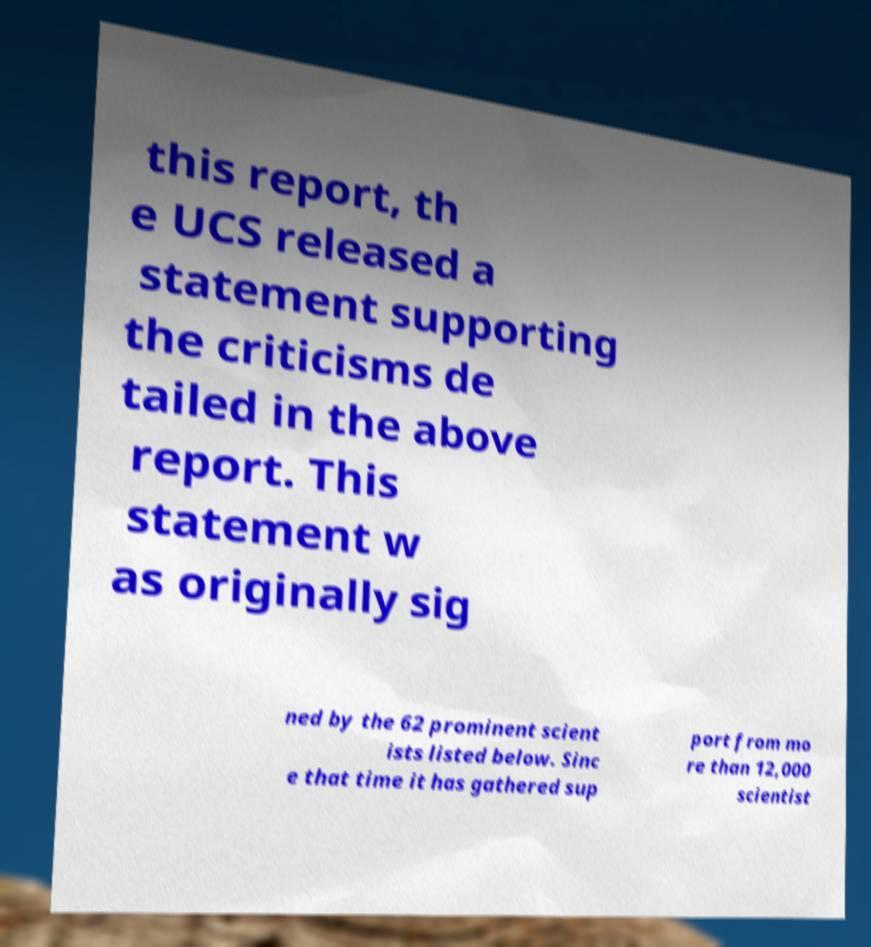Please identify and transcribe the text found in this image. this report, th e UCS released a statement supporting the criticisms de tailed in the above report. This statement w as originally sig ned by the 62 prominent scient ists listed below. Sinc e that time it has gathered sup port from mo re than 12,000 scientist 